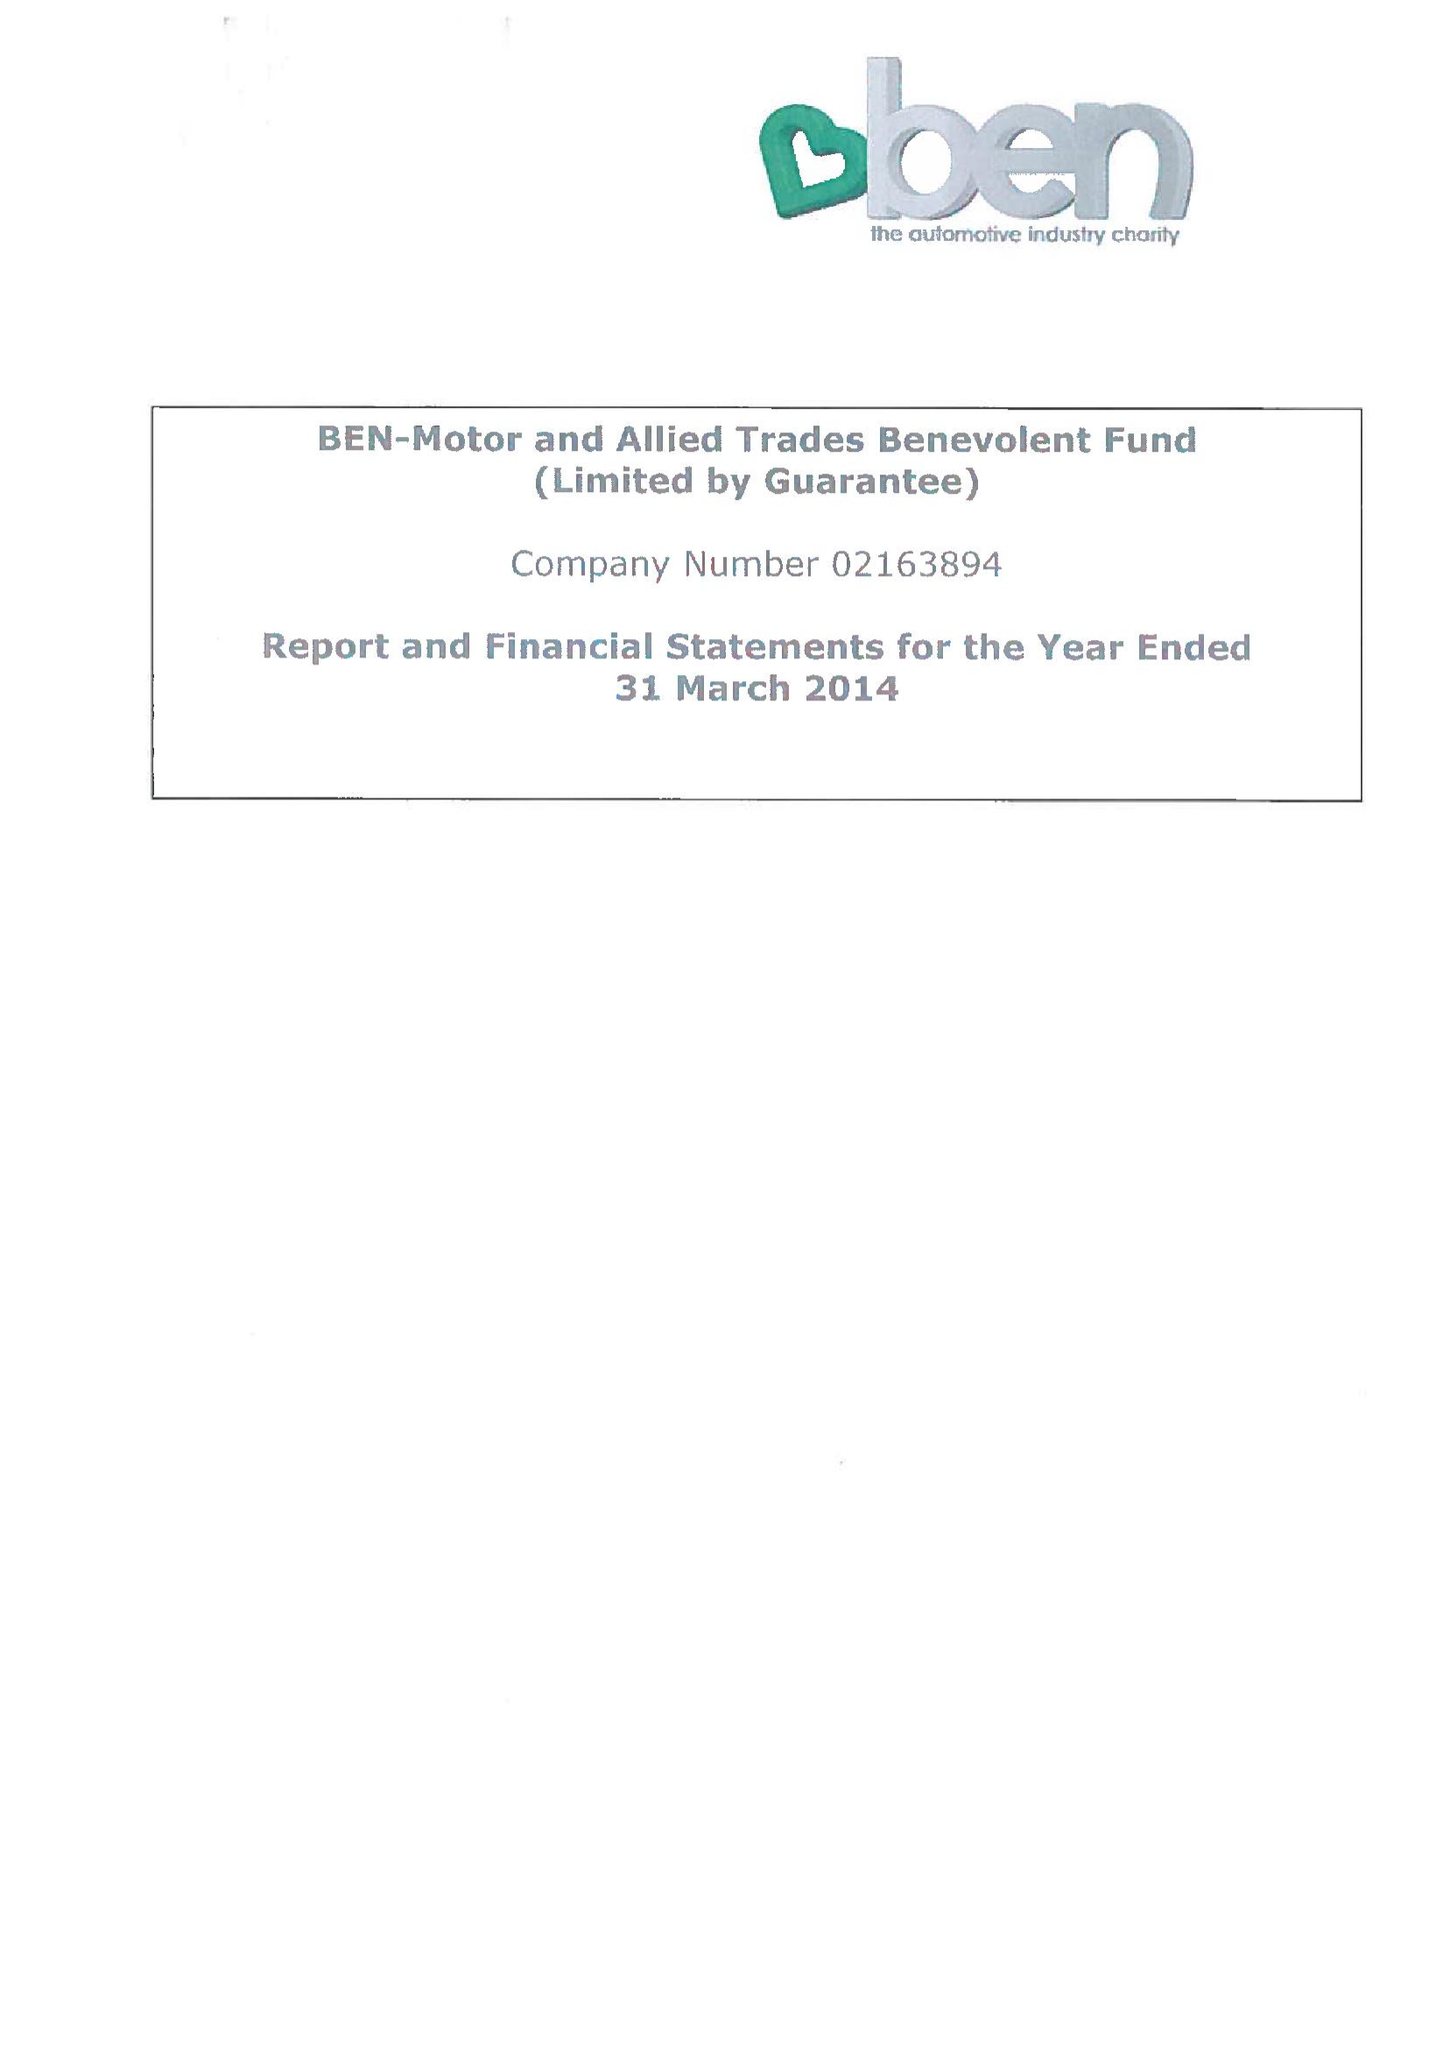What is the value for the charity_name?
Answer the question using a single word or phrase. Ben - Motor and Allied Trades Benevolent Fund 